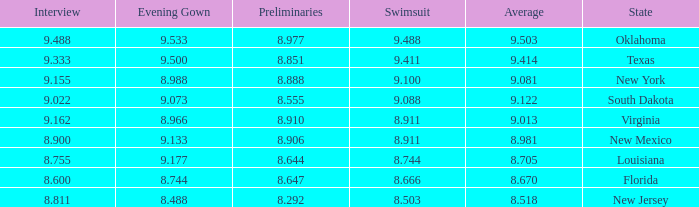 what's the swimsuit where average is 8.670 8.666. 